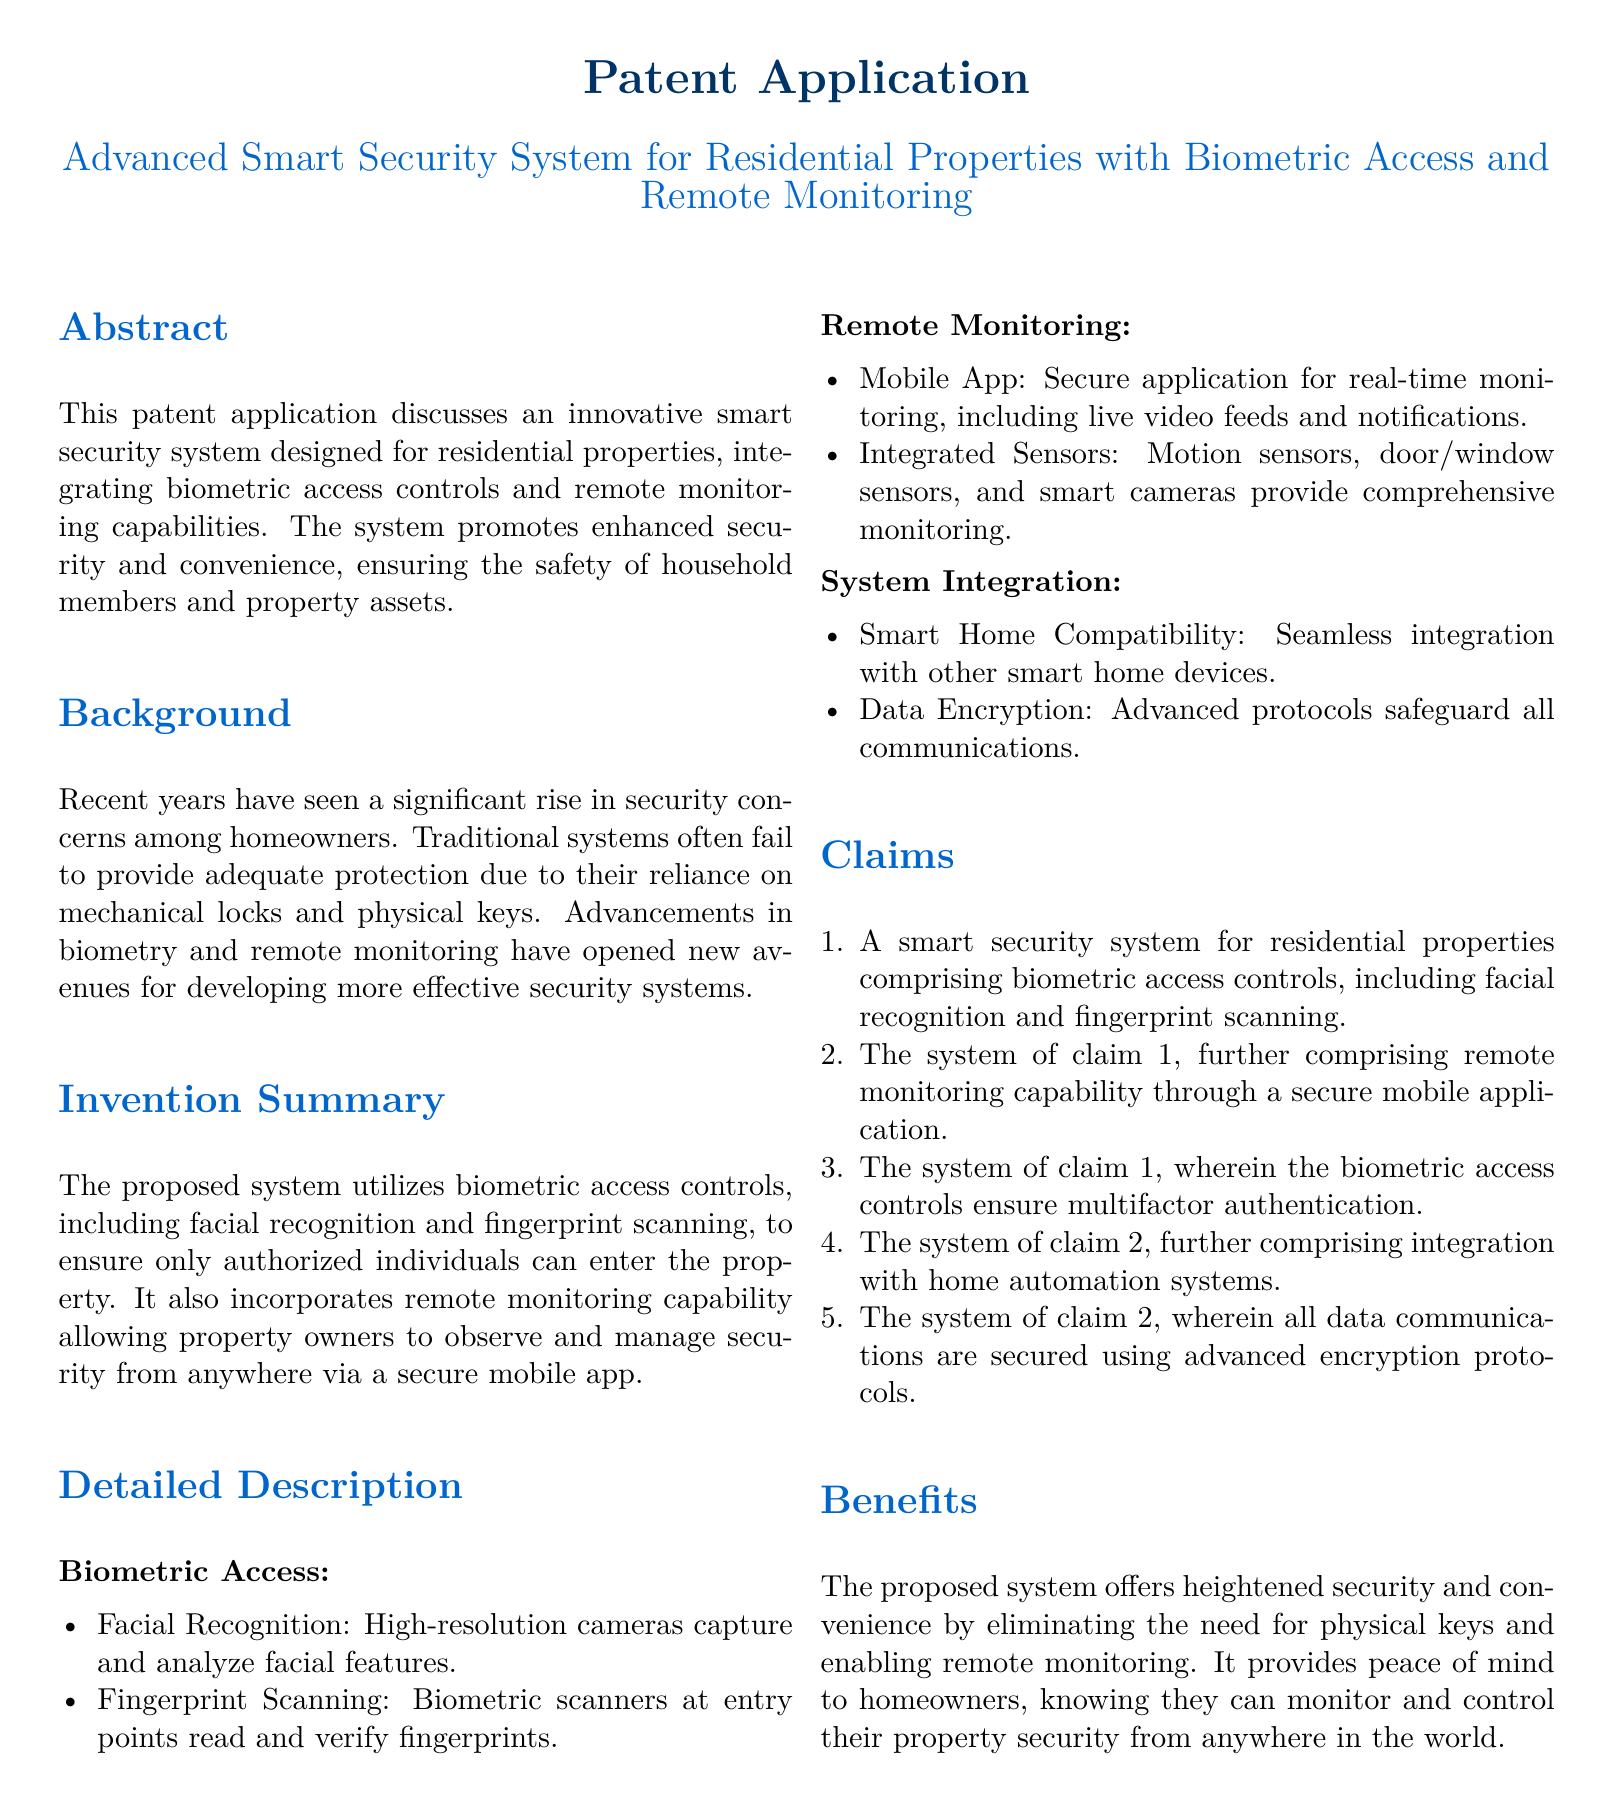What is the title of the patent application? The title of the patent application is located in the header section of the document.
Answer: Advanced Smart Security System for Residential Properties with Biometric Access and Remote Monitoring What key technology does the security system utilize? The key technology utilized by the security system is mentioned in the invention summary section.
Answer: Biometric access controls What is the main benefit of the proposed security system? The main benefit is described in the benefits section of the document.
Answer: Heightened security and convenience What types of biometric access controls are included in the system? The types are listed under the detailed description section, specifically in the biometric access subsection.
Answer: Facial recognition and fingerprint scanning What is the role of the mobile app in the system? The role of the mobile app is outlined in the remote monitoring section of the detailed description.
Answer: Real-time monitoring How many claims are listed in the patent application? The total number of claims is indicated by the enumeration in the claims section.
Answer: Five What type of home design compatibility is mentioned? This compatibility is specified in the system integration subsection of the detailed description.
Answer: Smart home compatibility What ensures that data communications are secure? The document specifies the security measure in the system integration subsection.
Answer: Advanced encryption protocols 